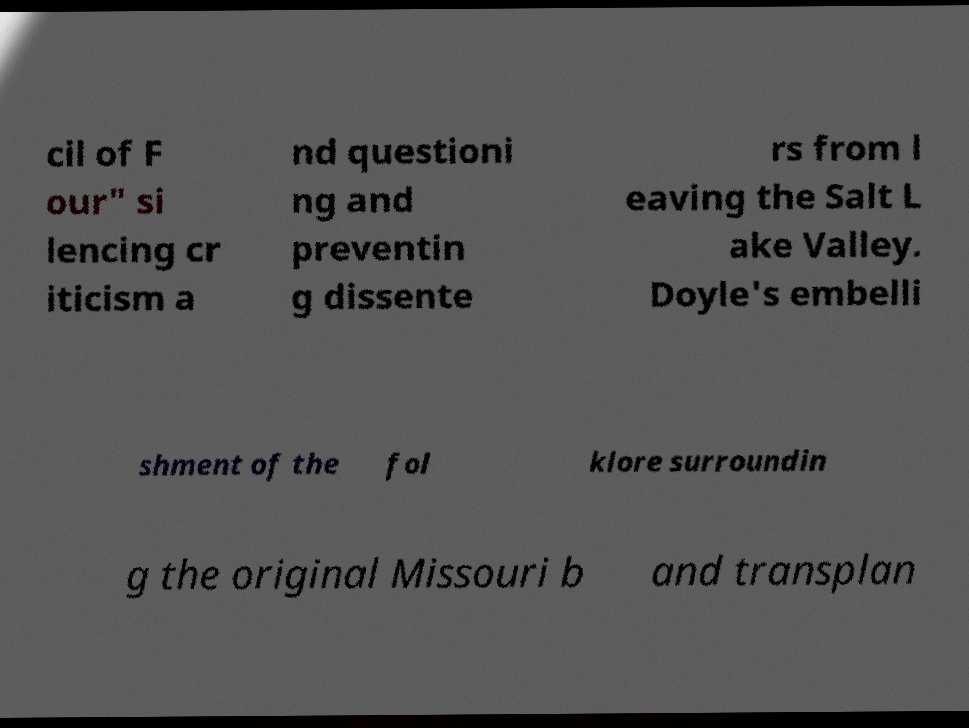What messages or text are displayed in this image? I need them in a readable, typed format. cil of F our" si lencing cr iticism a nd questioni ng and preventin g dissente rs from l eaving the Salt L ake Valley. Doyle's embelli shment of the fol klore surroundin g the original Missouri b and transplan 